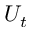Convert formula to latex. <formula><loc_0><loc_0><loc_500><loc_500>U _ { t }</formula> 